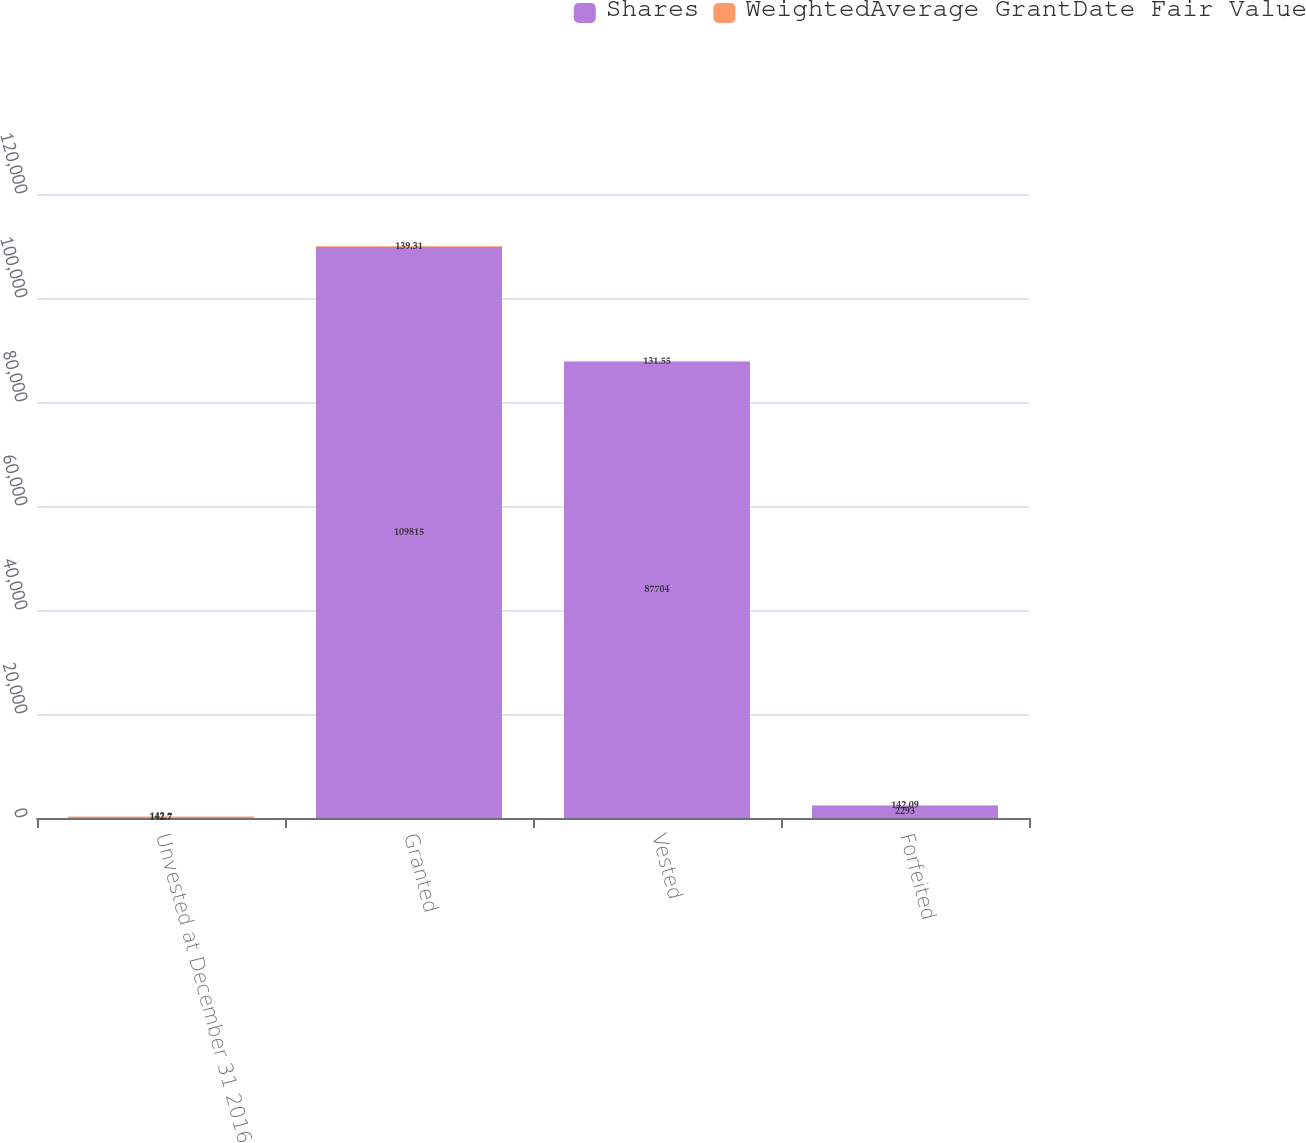Convert chart. <chart><loc_0><loc_0><loc_500><loc_500><stacked_bar_chart><ecel><fcel>Unvested at December 31 2016<fcel>Granted<fcel>Vested<fcel>Forfeited<nl><fcel>Shares<fcel>142.7<fcel>109815<fcel>87704<fcel>2293<nl><fcel>WeightedAverage GrantDate Fair Value<fcel>142.7<fcel>139.31<fcel>131.55<fcel>142.09<nl></chart> 